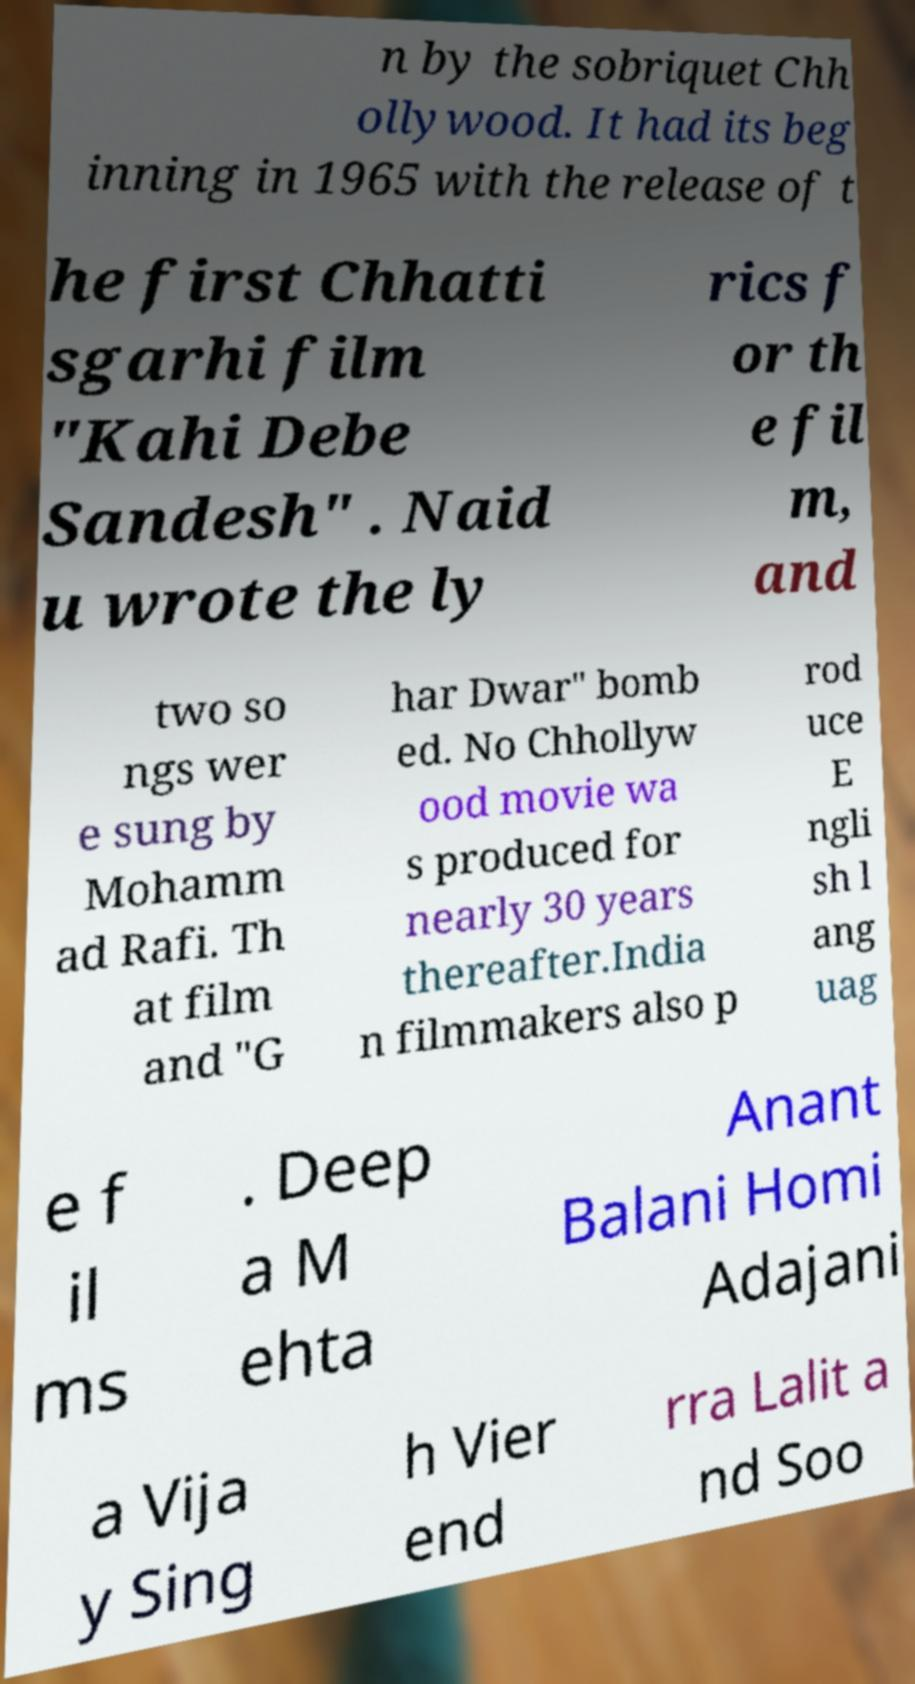For documentation purposes, I need the text within this image transcribed. Could you provide that? n by the sobriquet Chh ollywood. It had its beg inning in 1965 with the release of t he first Chhatti sgarhi film "Kahi Debe Sandesh" . Naid u wrote the ly rics f or th e fil m, and two so ngs wer e sung by Mohamm ad Rafi. Th at film and "G har Dwar" bomb ed. No Chhollyw ood movie wa s produced for nearly 30 years thereafter.India n filmmakers also p rod uce E ngli sh l ang uag e f il ms . Deep a M ehta Anant Balani Homi Adajani a Vija y Sing h Vier end rra Lalit a nd Soo 